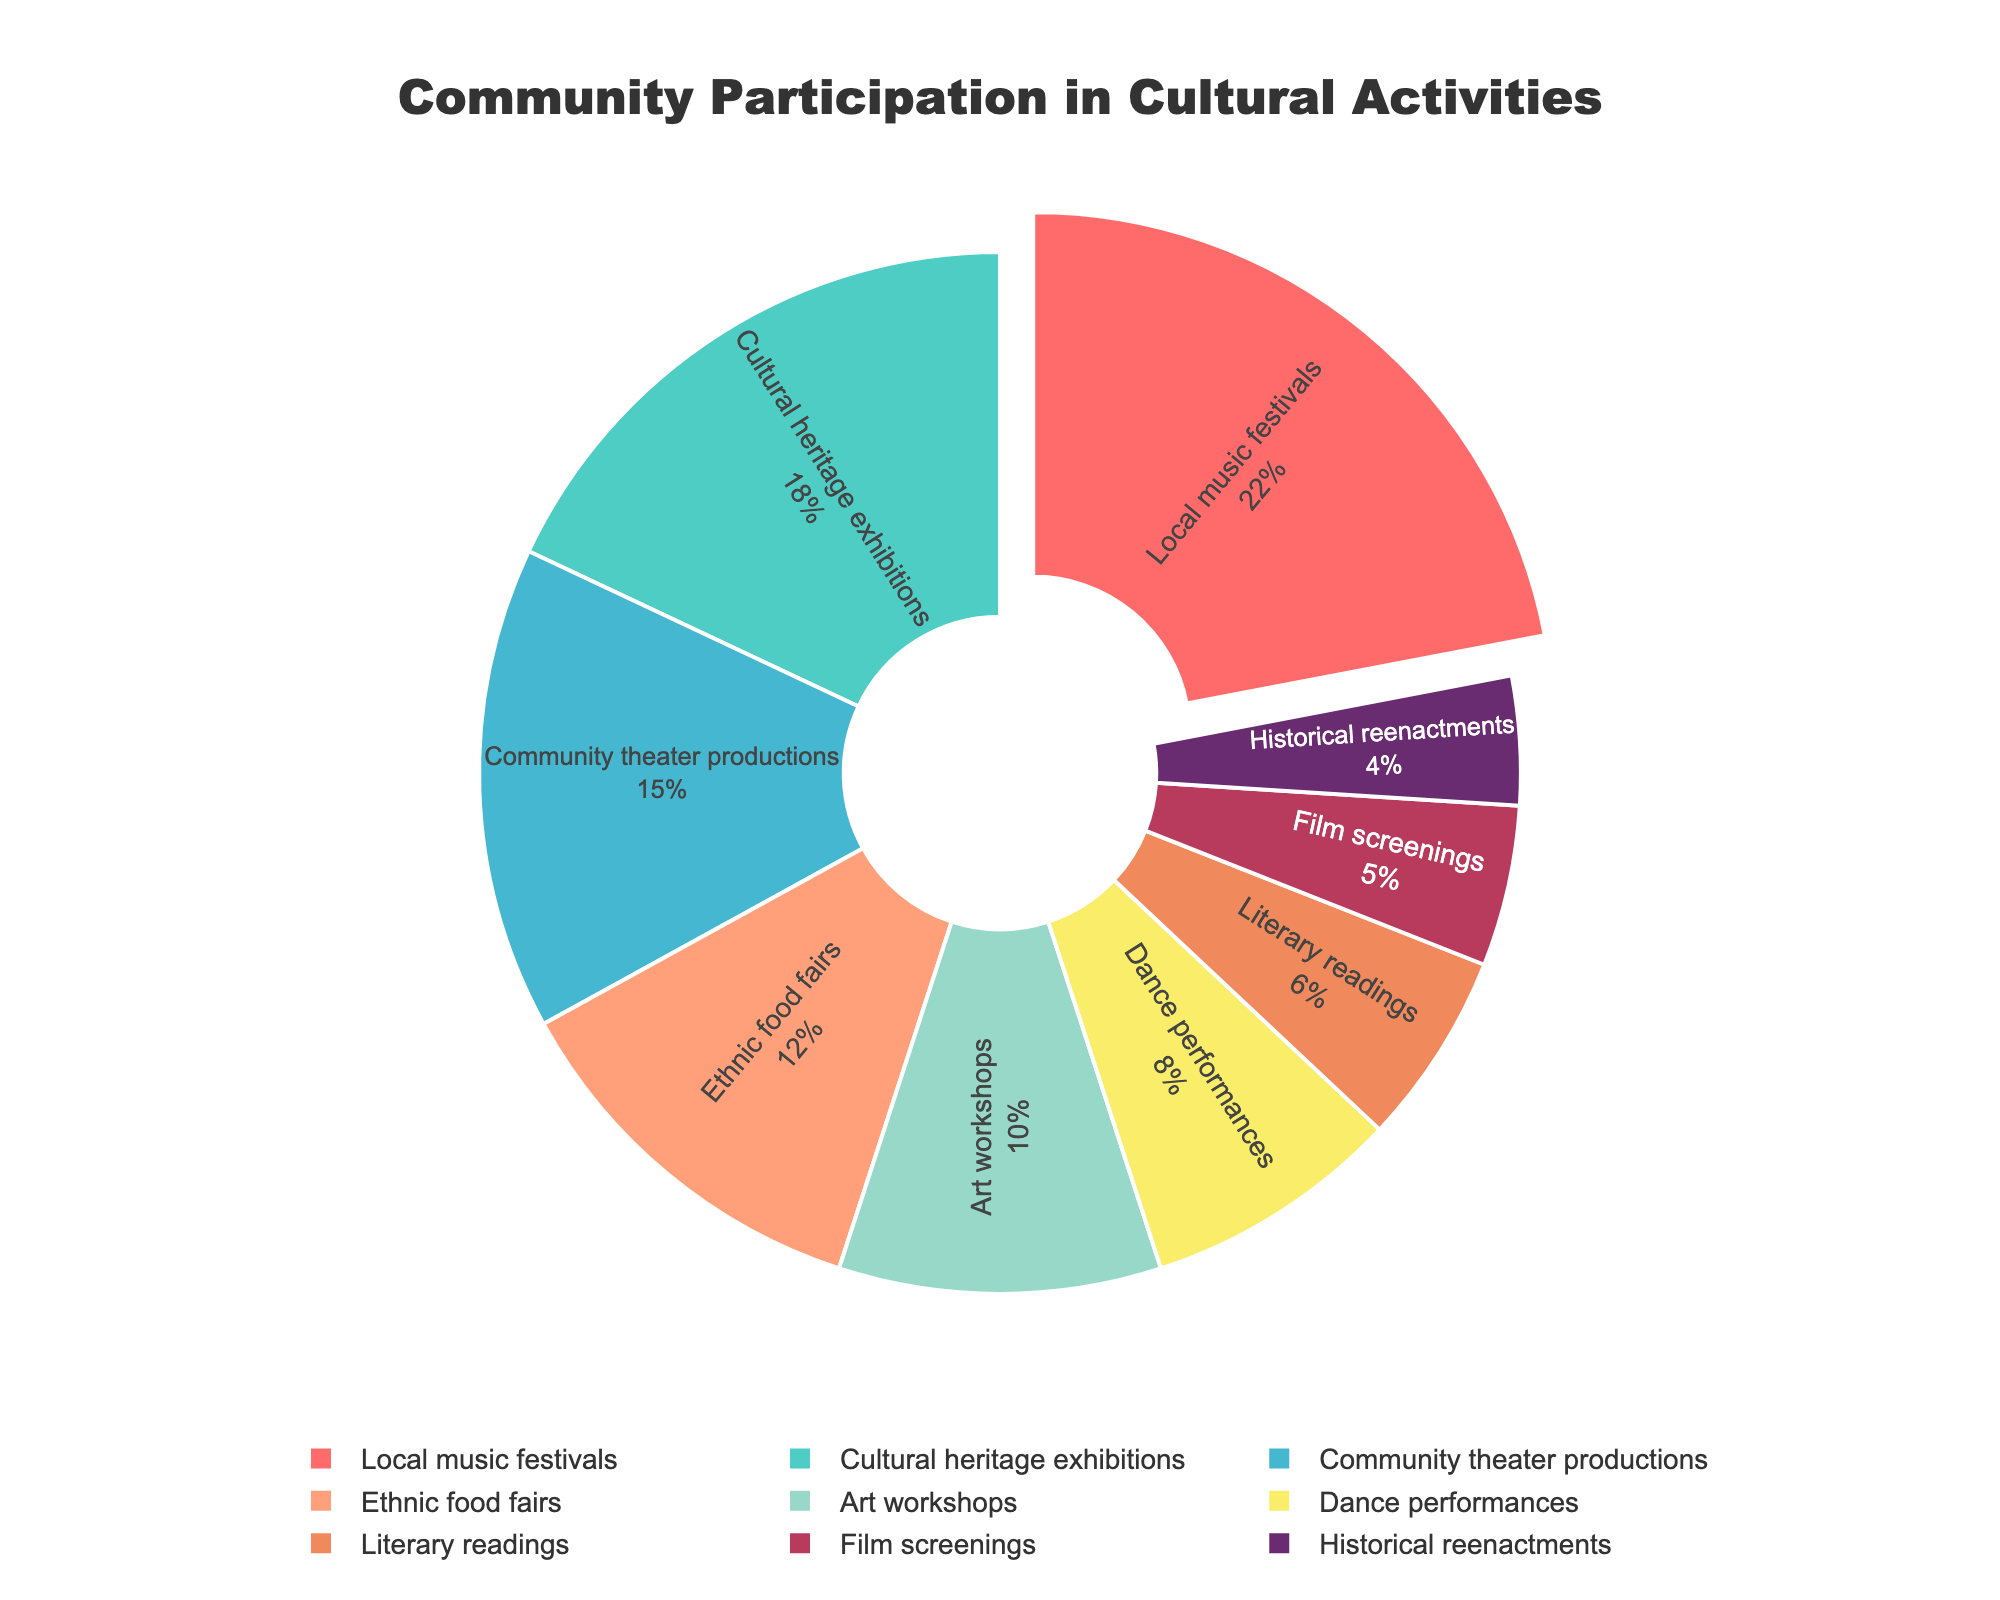What's the activity with the highest participation percentage? To identify the activity with the highest participation, we look for the largest segment in the pie chart. The largest segment corresponds to Local music festivals with 22%.
Answer: Local music festivals What is the combined percentage of participants in Community theater productions and Ethnic food fairs? To get the combined percentage, add the percentages of Community theater productions and Ethnic food fairs: 15% + 12% = 27%.
Answer: 27% Which activity has the smallest participation percentage, and what is it? To find the smallest participation percentage, look for the smallest segment in the pie chart. This corresponds to Historical reenactments with 4%.
Answer: Historical reenactments, 4% How does the participation in Art workshops compare to Dance performances? To compare participation, look at the percentage values for both activities. Art workshops have 10% and Dance performances have 8%. Therefore, Art workshops have a higher participation rate.
Answer: Art workshops have a higher participation rate Which activity is represented by the red segment, and what is its participation percentage? Locate the red segment in the pie chart. The red color segment represents Local music festivals with a participation percentage of 22%.
Answer: Local music festivals, 22% What's the total percentage of participants in activities outside the top five in terms of participation? The top five activities are Local music festivals (22%), Cultural heritage exhibitions (18%), Community theater productions (15%), Ethnic food fairs (12%), and Art workshops (10%). Add the percentages of the remaining activities: Dance performances (8%), Literary readings (6%), Film screenings (5%), and Historical reenactments (4%). This sums up to 8% + 6% + 5% + 4% = 23%.
Answer: 23% What's the difference in participation percentages between Local music festivals and Cultural heritage exhibitions? To find the difference, subtract the percentage of Cultural heritage exhibitions (18%) from Local music festivals (22%): 22% - 18% = 4%.
Answer: 4% What activities together make up less than 20% of the total participation? Look for activities whose combined percentage is less than 20%. Historical reenactments (4%), Film screenings (5%), and Literary readings (6%) together sum to 4% + 5% + 6% = 15%, which is less than 20%.
Answer: Historical reenactments, Film screenings, Literary readings Which activities need more than 5% but less than 20% participation? Identify the segments whose percentages fall within this range: 5% < percentage < 20%. They are Cultural heritage exhibitions (18%), Community theater productions (15%), Ethnic food fairs (12%), and Art workshops (10%).
Answer: Cultural heritage exhibitions, Community theater productions, Ethnic food fairs, Art workshops 